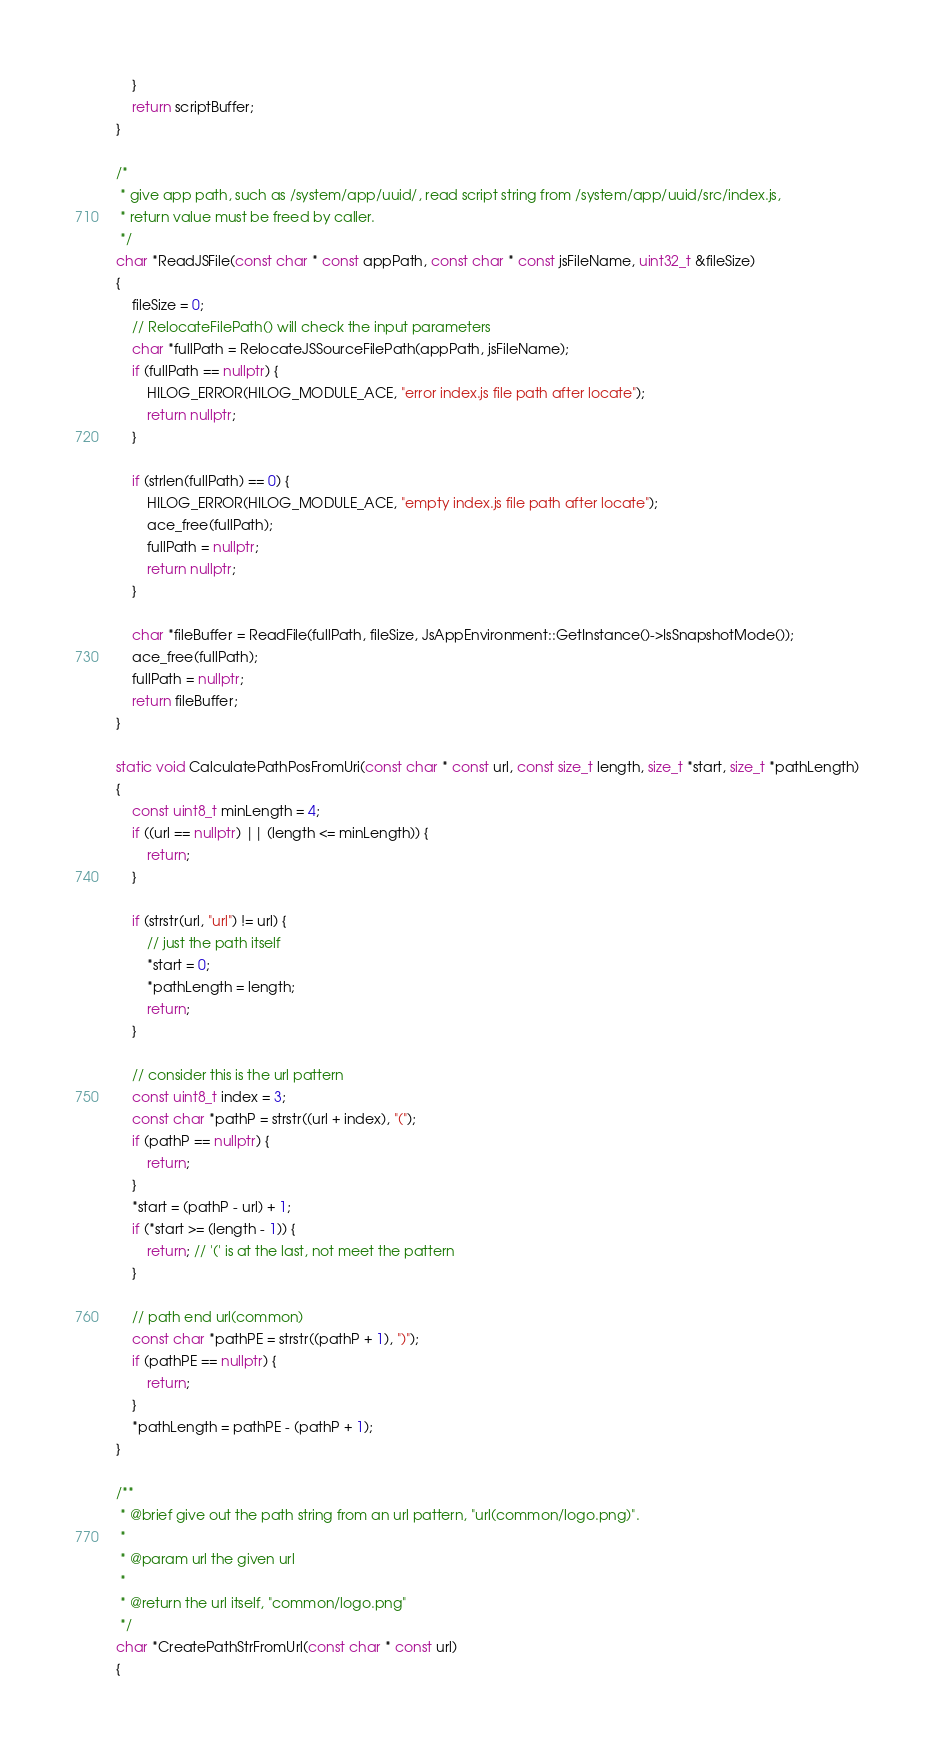<code> <loc_0><loc_0><loc_500><loc_500><_C++_>    }
    return scriptBuffer;
}

/*
 * give app path, such as /system/app/uuid/, read script string from /system/app/uuid/src/index.js,
 * return value must be freed by caller.
 */
char *ReadJSFile(const char * const appPath, const char * const jsFileName, uint32_t &fileSize)
{
    fileSize = 0;
    // RelocateFilePath() will check the input parameters
    char *fullPath = RelocateJSSourceFilePath(appPath, jsFileName);
    if (fullPath == nullptr) {
        HILOG_ERROR(HILOG_MODULE_ACE, "error index.js file path after locate");
        return nullptr;
    }

    if (strlen(fullPath) == 0) {
        HILOG_ERROR(HILOG_MODULE_ACE, "empty index.js file path after locate");
        ace_free(fullPath);
        fullPath = nullptr;
        return nullptr;
    }

    char *fileBuffer = ReadFile(fullPath, fileSize, JsAppEnvironment::GetInstance()->IsSnapshotMode());
    ace_free(fullPath);
    fullPath = nullptr;
    return fileBuffer;
}

static void CalculatePathPosFromUri(const char * const url, const size_t length, size_t *start, size_t *pathLength)
{
    const uint8_t minLength = 4;
    if ((url == nullptr) || (length <= minLength)) {
        return;
    }

    if (strstr(url, "url") != url) {
        // just the path itself
        *start = 0;
        *pathLength = length;
        return;
    }

    // consider this is the url pattern
    const uint8_t index = 3;
    const char *pathP = strstr((url + index), "(");
    if (pathP == nullptr) {
        return;
    }
    *start = (pathP - url) + 1;
    if (*start >= (length - 1)) {
        return; // '(' is at the last, not meet the pattern
    }

    // path end url(common)
    const char *pathPE = strstr((pathP + 1), ")");
    if (pathPE == nullptr) {
        return;
    }
    *pathLength = pathPE - (pathP + 1);
}

/**
 * @brief give out the path string from an url pattern, "url(common/logo.png)".
 *
 * @param url the given url
 *
 * @return the url itself, "common/logo.png"
 */
char *CreatePathStrFromUrl(const char * const url)
{</code> 